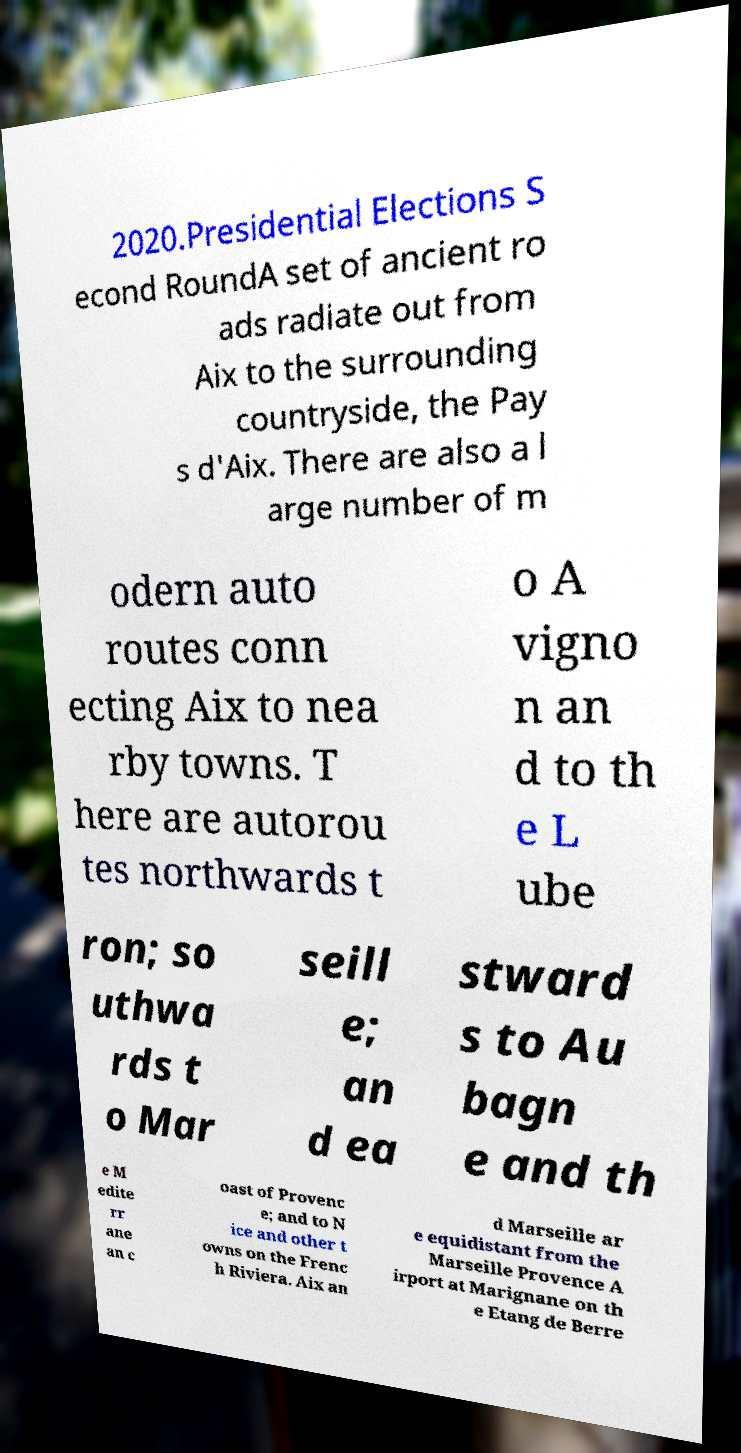There's text embedded in this image that I need extracted. Can you transcribe it verbatim? 2020.Presidential Elections S econd RoundA set of ancient ro ads radiate out from Aix to the surrounding countryside, the Pay s d'Aix. There are also a l arge number of m odern auto routes conn ecting Aix to nea rby towns. T here are autorou tes northwards t o A vigno n an d to th e L ube ron; so uthwa rds t o Mar seill e; an d ea stward s to Au bagn e and th e M edite rr ane an c oast of Provenc e; and to N ice and other t owns on the Frenc h Riviera. Aix an d Marseille ar e equidistant from the Marseille Provence A irport at Marignane on th e Etang de Berre 